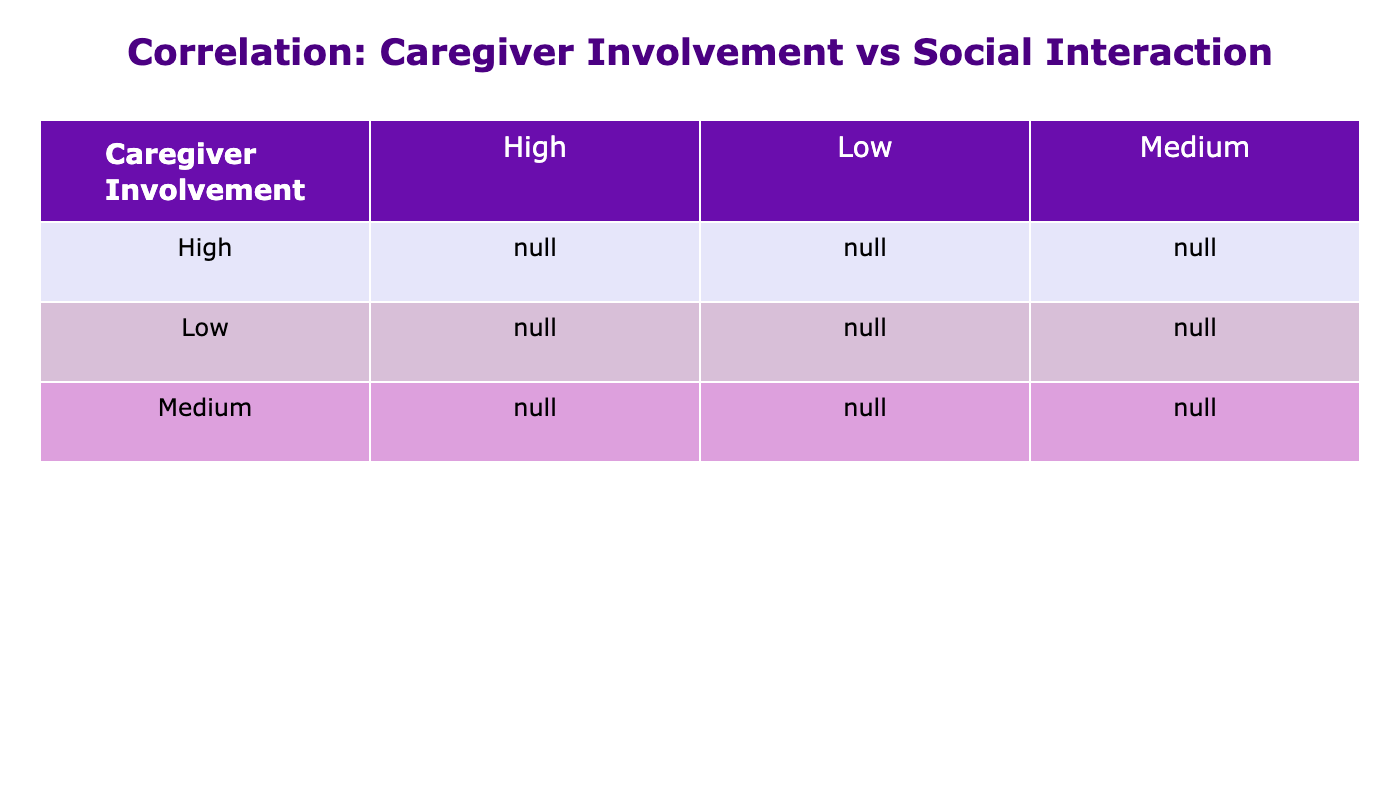What is the average social interaction level for participants with high caregiver involvement? The social interaction levels for high caregiver involvement are 8, 7, 9, 9, and 8. To find the average, sum these values (8 + 7 + 9 + 9 + 8 = 41) and then divide by the number of values (5). So, the average is 41/5 = 8.2.
Answer: 8.2 What is the correlation coefficient between caregiver involvement and social interaction levels? The correlation coefficients are derived from the table. High involvement shows an average of 8.2, medium shows 6, and low shows 4. The correlation is likely strong since increased caregiver involvement is linked to higher social interaction levels. The exact correlation value can typically be calculated from the full dataset but can be inferred to be positive from these averages.
Answer: Positive correlation Is the social interaction level higher for medium caregiver involvement compared to low involvement? The average social interaction level for medium involvement is 6, while for low involvement, it is 4. Since 6 is greater than 4, the statement is true.
Answer: Yes How many participants in the low involvement group had a social interaction level of 3 or higher? The low involvement levels are 4, 3, 5, 2, 3. The values 4, 3, 5, and 3 are greater than or equal to 3. Counting these gives us 4 participants.
Answer: 4 What is the difference in average social interaction levels between medium and high caregiver involvement? The average for medium caregiver involvement is 6, and for high involvement, it is 8.2. To find the difference, subtract the average of medium (6) from the average of high (8.2). Thus, 8.2 - 6 = 2.2.
Answer: 2.2 Are there more data points for high involvement than for low involvement? In the dataset, there are 5 high involvement data points (8, 7, 9, 9, 8) and 4 low involvement data points (4, 3, 5, 2, 3). Since 5 is greater than 4, the statement is true.
Answer: Yes What would be the total social interaction level for all participants with medium caregiver involvement? The social interaction levels for medium involvement are 6, 5, 7, 6, and 5. To get the total, add these values: 6 + 5 + 7 + 6 + 5 = 29.
Answer: 29 What is the highest social interaction level recorded in the table, and for which caregiver involvement level was it recorded? The highest social interaction level present in the data is 9, recorded under high caregiver involvement.
Answer: 9, high involvement 